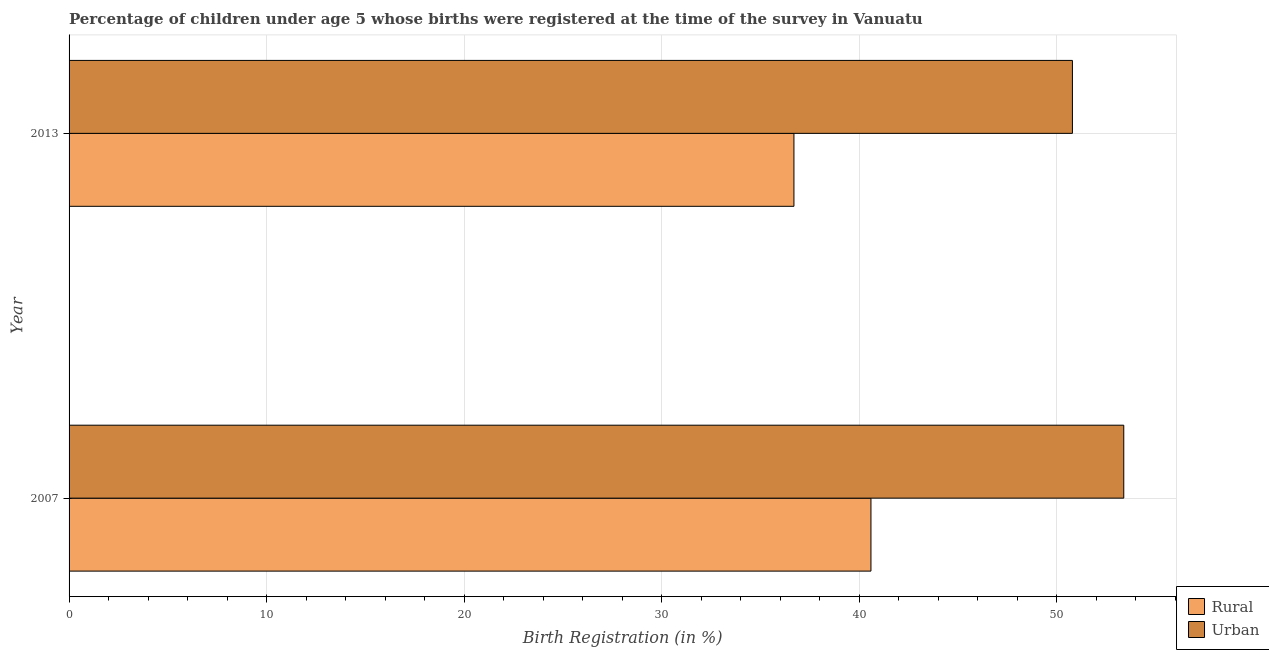How many groups of bars are there?
Your response must be concise. 2. How many bars are there on the 1st tick from the top?
Keep it short and to the point. 2. What is the urban birth registration in 2013?
Give a very brief answer. 50.8. Across all years, what is the maximum rural birth registration?
Provide a short and direct response. 40.6. Across all years, what is the minimum rural birth registration?
Provide a succinct answer. 36.7. What is the total urban birth registration in the graph?
Offer a very short reply. 104.2. What is the difference between the rural birth registration in 2007 and that in 2013?
Your answer should be very brief. 3.9. What is the difference between the urban birth registration in 2007 and the rural birth registration in 2013?
Ensure brevity in your answer.  16.7. What is the average rural birth registration per year?
Your answer should be very brief. 38.65. In the year 2013, what is the difference between the urban birth registration and rural birth registration?
Your answer should be compact. 14.1. What is the ratio of the urban birth registration in 2007 to that in 2013?
Keep it short and to the point. 1.05. Is the urban birth registration in 2007 less than that in 2013?
Your answer should be very brief. No. Is the difference between the rural birth registration in 2007 and 2013 greater than the difference between the urban birth registration in 2007 and 2013?
Keep it short and to the point. Yes. What does the 1st bar from the top in 2007 represents?
Provide a succinct answer. Urban. What does the 2nd bar from the bottom in 2013 represents?
Make the answer very short. Urban. Are all the bars in the graph horizontal?
Make the answer very short. Yes. How many years are there in the graph?
Keep it short and to the point. 2. What is the difference between two consecutive major ticks on the X-axis?
Ensure brevity in your answer.  10. Are the values on the major ticks of X-axis written in scientific E-notation?
Ensure brevity in your answer.  No. Does the graph contain any zero values?
Offer a terse response. No. Does the graph contain grids?
Offer a very short reply. Yes. How many legend labels are there?
Your response must be concise. 2. What is the title of the graph?
Provide a succinct answer. Percentage of children under age 5 whose births were registered at the time of the survey in Vanuatu. Does "Personal remittances" appear as one of the legend labels in the graph?
Your answer should be very brief. No. What is the label or title of the X-axis?
Provide a short and direct response. Birth Registration (in %). What is the Birth Registration (in %) of Rural in 2007?
Provide a short and direct response. 40.6. What is the Birth Registration (in %) in Urban in 2007?
Make the answer very short. 53.4. What is the Birth Registration (in %) of Rural in 2013?
Give a very brief answer. 36.7. What is the Birth Registration (in %) of Urban in 2013?
Provide a succinct answer. 50.8. Across all years, what is the maximum Birth Registration (in %) of Rural?
Ensure brevity in your answer.  40.6. Across all years, what is the maximum Birth Registration (in %) in Urban?
Offer a very short reply. 53.4. Across all years, what is the minimum Birth Registration (in %) of Rural?
Offer a terse response. 36.7. Across all years, what is the minimum Birth Registration (in %) of Urban?
Your response must be concise. 50.8. What is the total Birth Registration (in %) of Rural in the graph?
Your answer should be very brief. 77.3. What is the total Birth Registration (in %) in Urban in the graph?
Ensure brevity in your answer.  104.2. What is the difference between the Birth Registration (in %) of Rural in 2007 and that in 2013?
Offer a very short reply. 3.9. What is the difference between the Birth Registration (in %) of Urban in 2007 and that in 2013?
Your answer should be compact. 2.6. What is the average Birth Registration (in %) of Rural per year?
Provide a short and direct response. 38.65. What is the average Birth Registration (in %) of Urban per year?
Ensure brevity in your answer.  52.1. In the year 2013, what is the difference between the Birth Registration (in %) in Rural and Birth Registration (in %) in Urban?
Keep it short and to the point. -14.1. What is the ratio of the Birth Registration (in %) in Rural in 2007 to that in 2013?
Offer a very short reply. 1.11. What is the ratio of the Birth Registration (in %) in Urban in 2007 to that in 2013?
Your response must be concise. 1.05. What is the difference between the highest and the second highest Birth Registration (in %) in Urban?
Keep it short and to the point. 2.6. What is the difference between the highest and the lowest Birth Registration (in %) in Urban?
Offer a terse response. 2.6. 